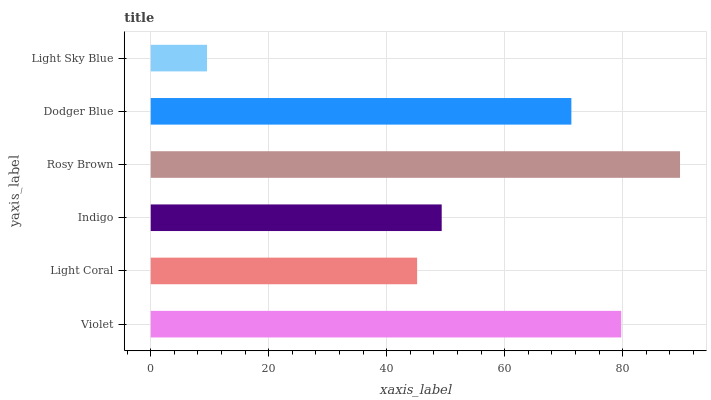Is Light Sky Blue the minimum?
Answer yes or no. Yes. Is Rosy Brown the maximum?
Answer yes or no. Yes. Is Light Coral the minimum?
Answer yes or no. No. Is Light Coral the maximum?
Answer yes or no. No. Is Violet greater than Light Coral?
Answer yes or no. Yes. Is Light Coral less than Violet?
Answer yes or no. Yes. Is Light Coral greater than Violet?
Answer yes or no. No. Is Violet less than Light Coral?
Answer yes or no. No. Is Dodger Blue the high median?
Answer yes or no. Yes. Is Indigo the low median?
Answer yes or no. Yes. Is Light Sky Blue the high median?
Answer yes or no. No. Is Rosy Brown the low median?
Answer yes or no. No. 